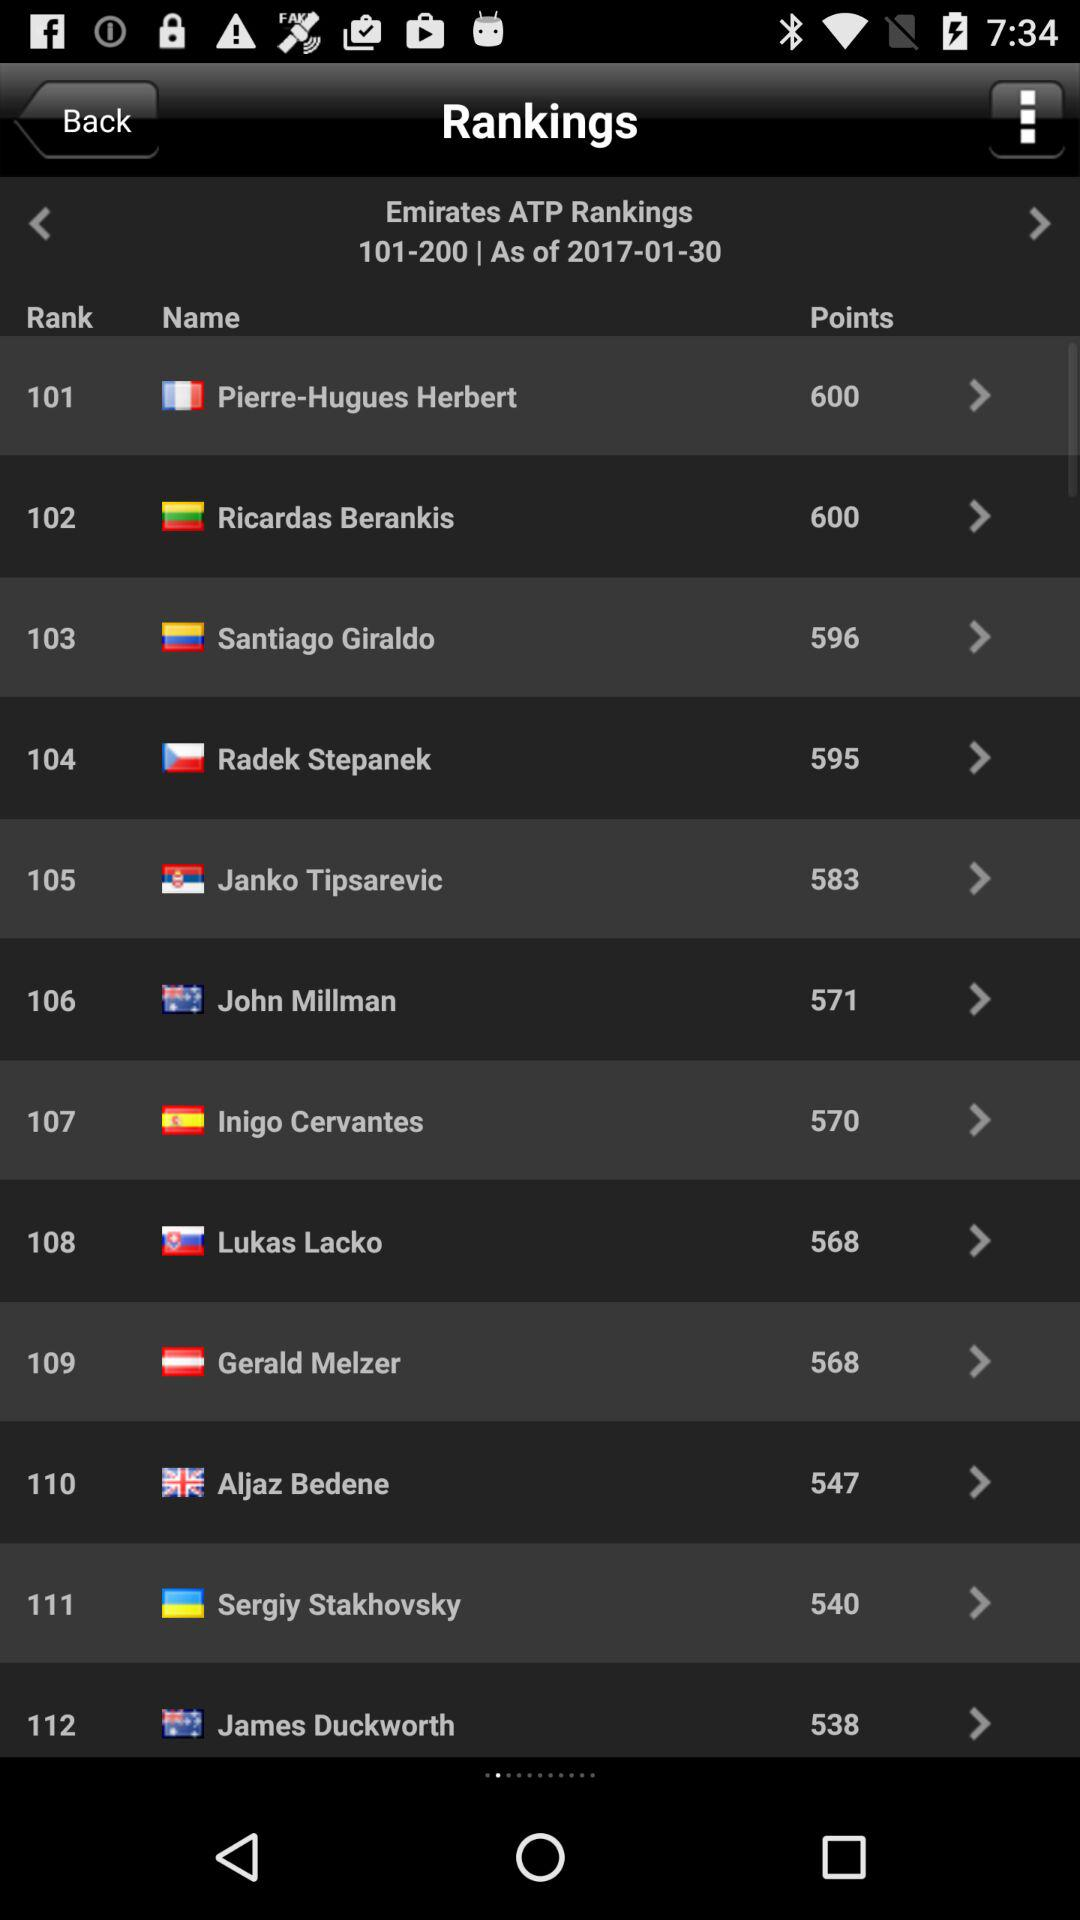How many points does Ricardas Berankis have? Ricardas Berankis has 600 points. 